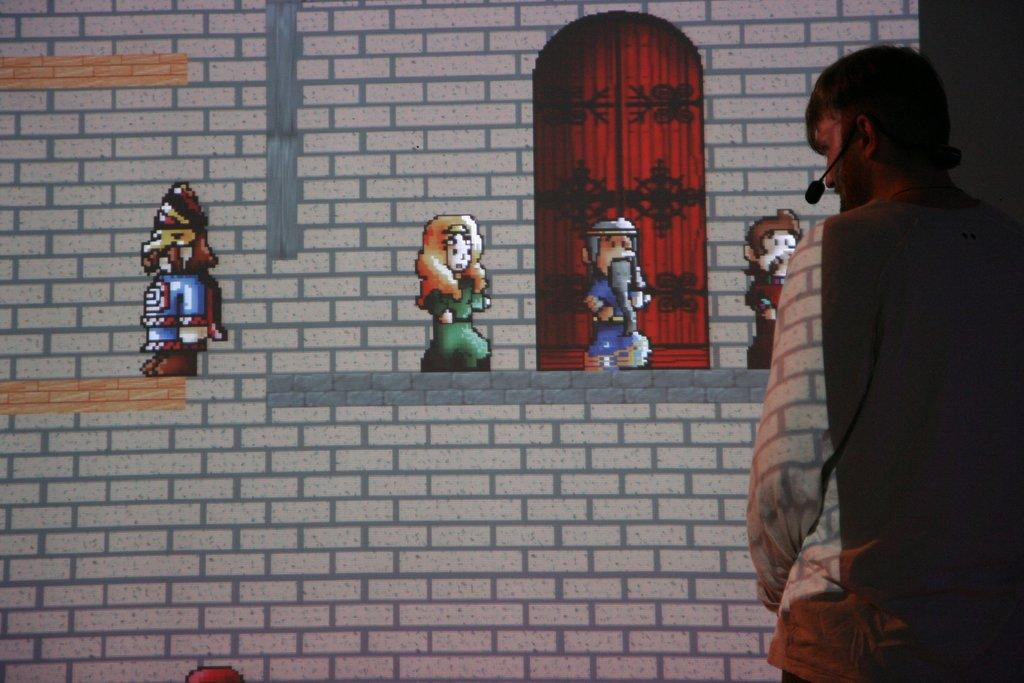Who or what is present in the image? There is a person in the image. What is the person wearing? The person is wearing a microphone. What can be seen in the background of the image? There is a wall in the background of the image. What is on the wall in the background? There are pictures on the wall in the background. What type of brush is being used to paint the dock in the image? There is no brush or dock present in the image; it features a person wearing a microphone with a wall and pictures in the background. 